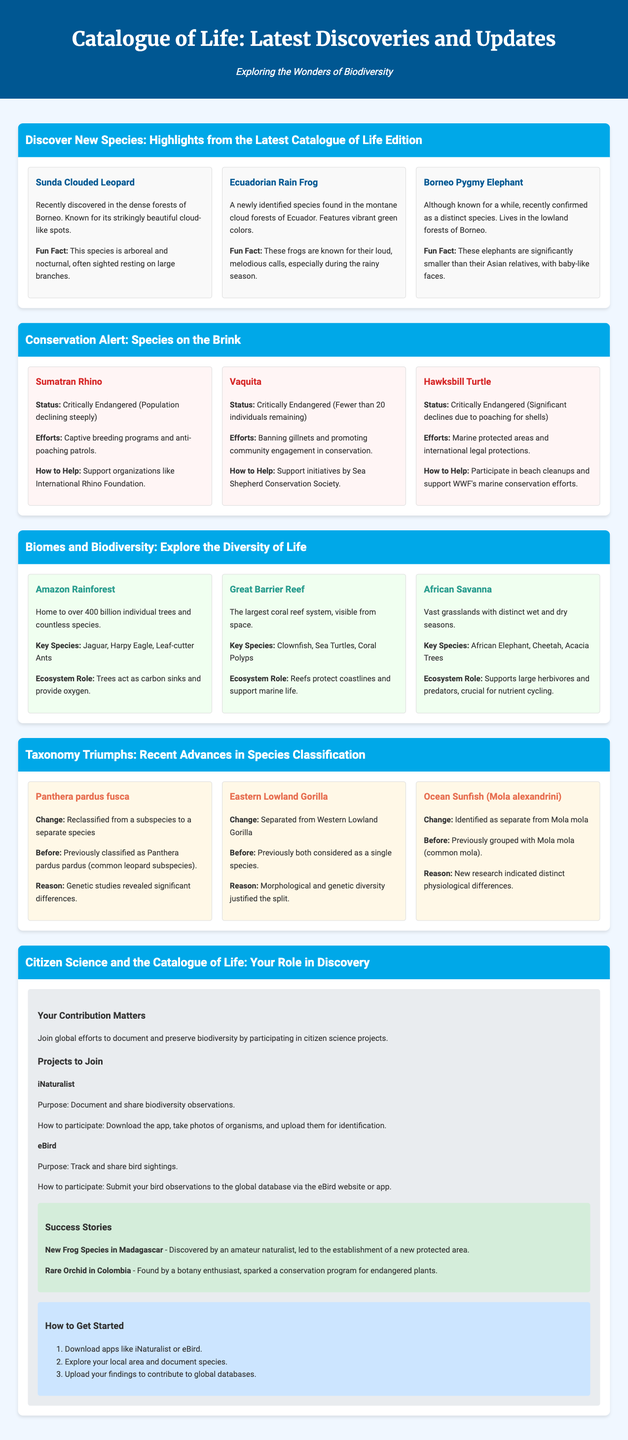What is the striking feature of the Sunda Clouded Leopard? The Sunda Clouded Leopard is known for its strikingly beautiful cloud-like spots.
Answer: cloud-like spots How many individuals of Vaquita are remaining? The document states that there are fewer than 20 individuals remaining of the Vaquita species.
Answer: fewer than 20 What is the conservation status of the Sumatran Rhino? The document describes the Sumatran Rhino as Critically Endangered, with a population declining steeply.
Answer: Critically Endangered Which biome is home to the Harpy Eagle? The Harpy Eagle is a key species in the Amazon Rainforest biome.
Answer: Amazon Rainforest What was Panthera pardus fusca classified as previously? Panthera pardus fusca was previously classified as a subspecies of Panthera pardus pardus.
Answer: Panthera pardus pardus What is the purpose of the iNaturalist project? The iNaturalist project aims to document and share biodiversity observations.
Answer: Document and share biodiversity observations What role do trees play in the Amazon Rainforest ecosystem? Trees act as carbon sinks and provide oxygen in the Amazon Rainforest ecosystem.
Answer: carbon sinks and provide oxygen What notable discovery did an amateur naturalist contribute to? An amateur naturalist contributed to the discovery of a new frog species in Madagascar.
Answer: new frog species in Madagascar 